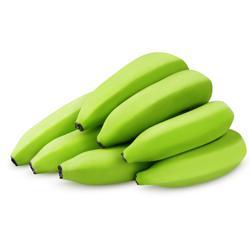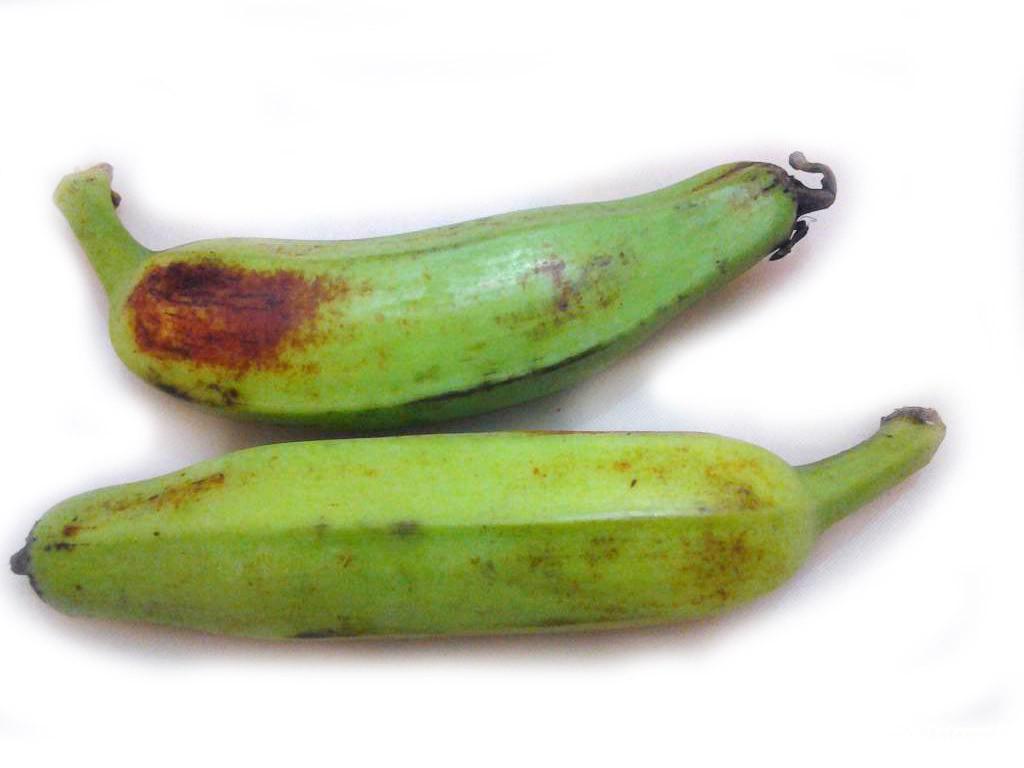The first image is the image on the left, the second image is the image on the right. For the images displayed, is the sentence "One image contains three or less plantains, the other contains more than six bananas." factually correct? Answer yes or no. Yes. The first image is the image on the left, the second image is the image on the right. Given the left and right images, does the statement "An image contains no more than three bananas, and the bananas have some brownish patches." hold true? Answer yes or no. Yes. 